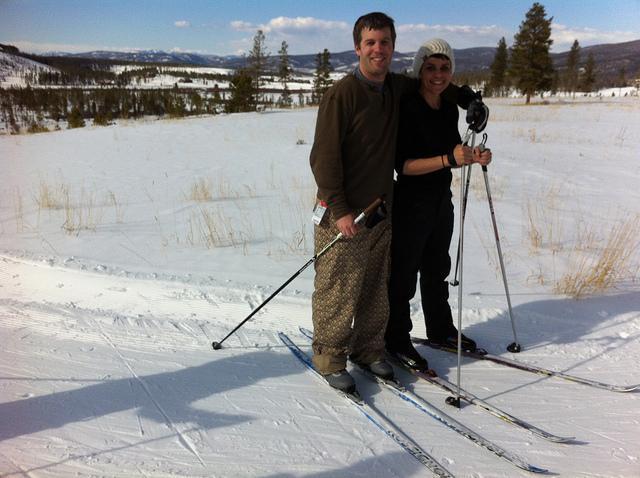How many ski are in the picture?
Give a very brief answer. 2. How many people are there?
Give a very brief answer. 2. How many buses are red and white striped?
Give a very brief answer. 0. 